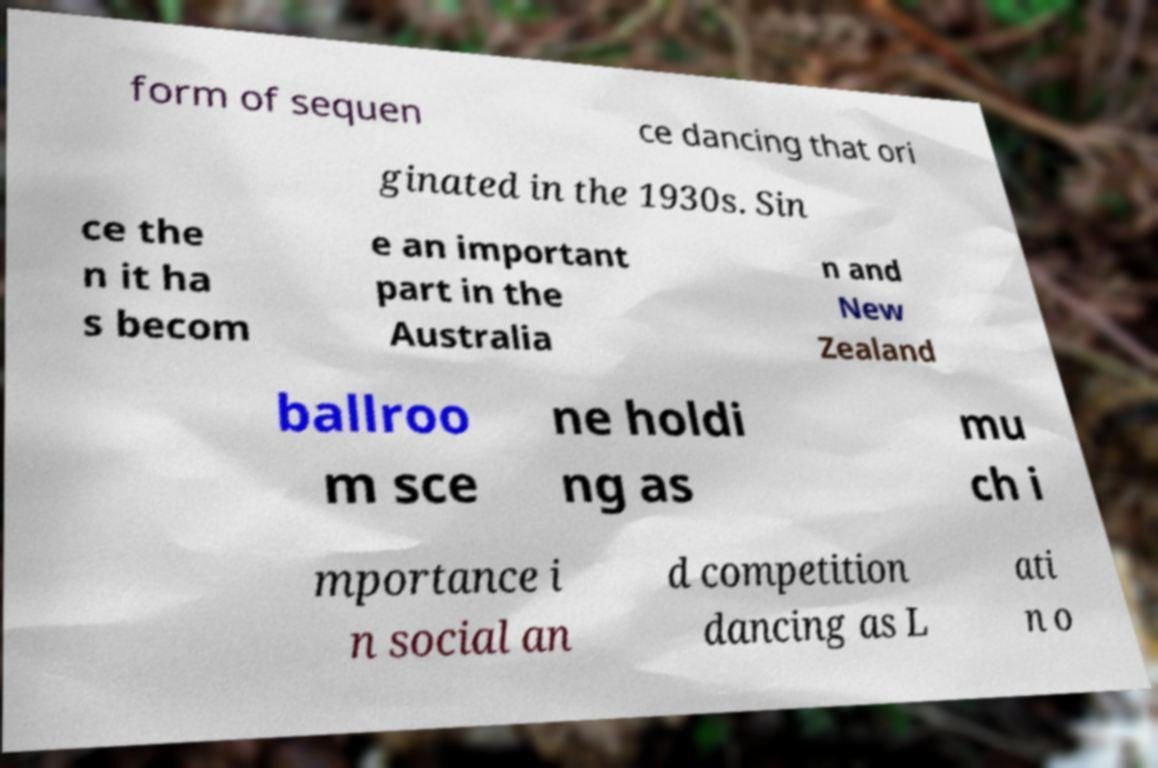Please identify and transcribe the text found in this image. form of sequen ce dancing that ori ginated in the 1930s. Sin ce the n it ha s becom e an important part in the Australia n and New Zealand ballroo m sce ne holdi ng as mu ch i mportance i n social an d competition dancing as L ati n o 